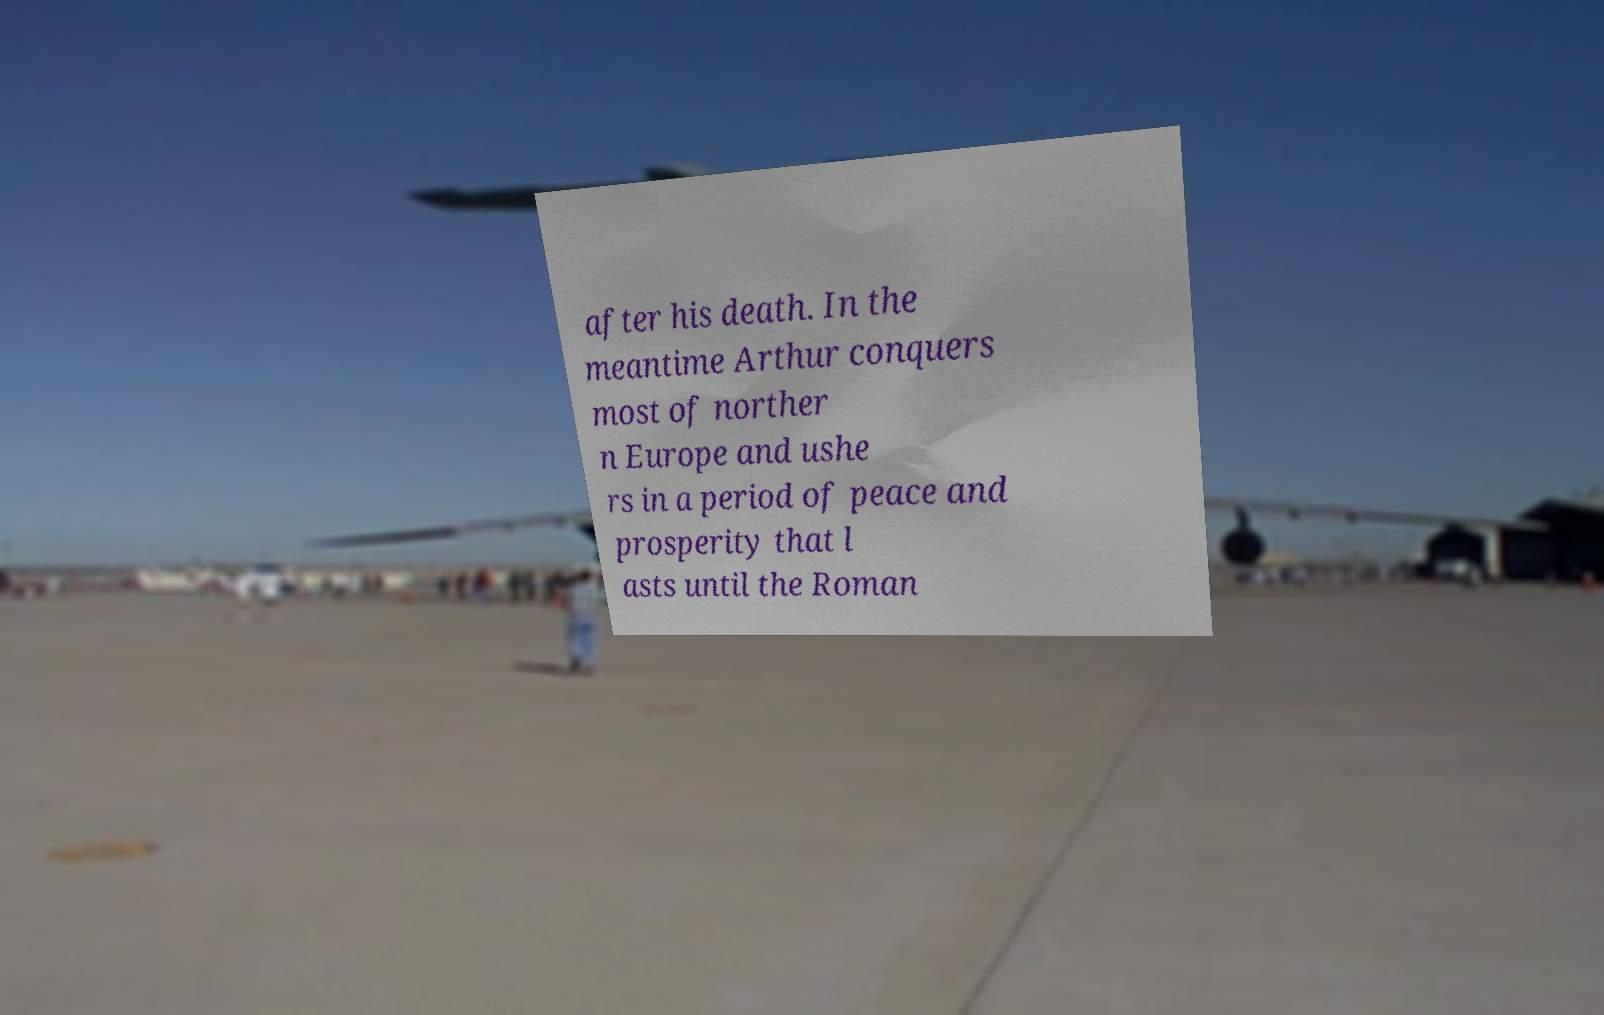For documentation purposes, I need the text within this image transcribed. Could you provide that? after his death. In the meantime Arthur conquers most of norther n Europe and ushe rs in a period of peace and prosperity that l asts until the Roman 